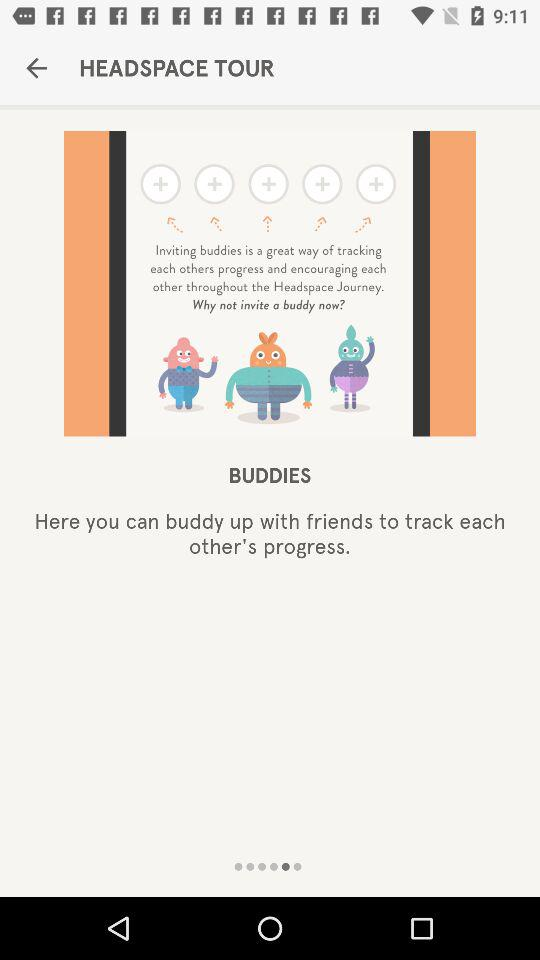With whom can I buddy up? You can buddy up with friends. 